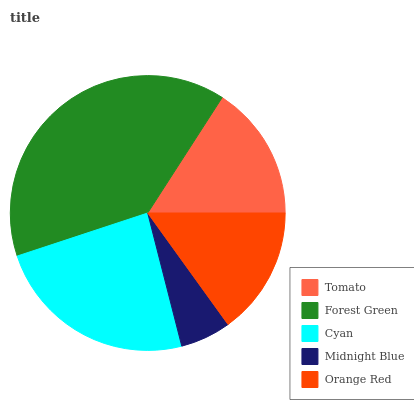Is Midnight Blue the minimum?
Answer yes or no. Yes. Is Forest Green the maximum?
Answer yes or no. Yes. Is Cyan the minimum?
Answer yes or no. No. Is Cyan the maximum?
Answer yes or no. No. Is Forest Green greater than Cyan?
Answer yes or no. Yes. Is Cyan less than Forest Green?
Answer yes or no. Yes. Is Cyan greater than Forest Green?
Answer yes or no. No. Is Forest Green less than Cyan?
Answer yes or no. No. Is Tomato the high median?
Answer yes or no. Yes. Is Tomato the low median?
Answer yes or no. Yes. Is Forest Green the high median?
Answer yes or no. No. Is Cyan the low median?
Answer yes or no. No. 